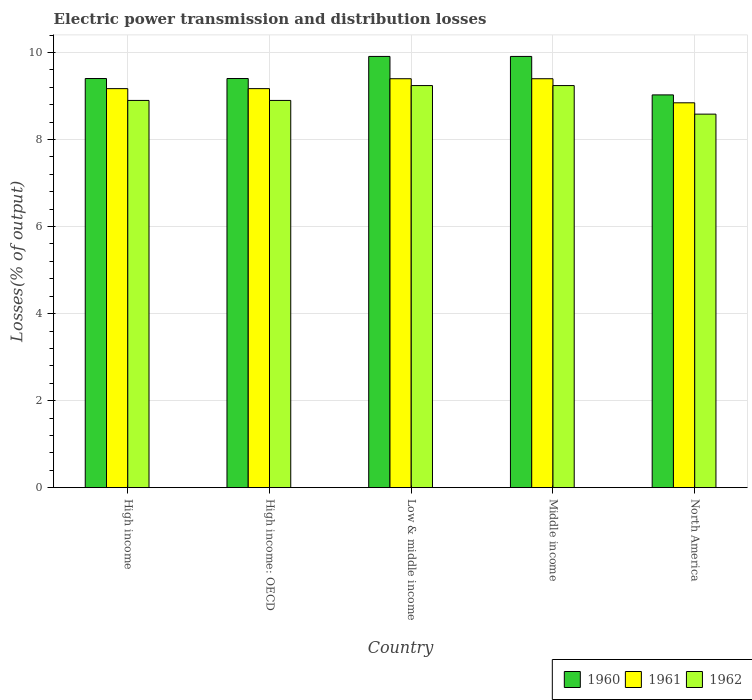How many groups of bars are there?
Your response must be concise. 5. Are the number of bars per tick equal to the number of legend labels?
Give a very brief answer. Yes. How many bars are there on the 4th tick from the left?
Your answer should be very brief. 3. What is the label of the 2nd group of bars from the left?
Keep it short and to the point. High income: OECD. What is the electric power transmission and distribution losses in 1960 in High income: OECD?
Make the answer very short. 9.4. Across all countries, what is the maximum electric power transmission and distribution losses in 1961?
Ensure brevity in your answer.  9.4. Across all countries, what is the minimum electric power transmission and distribution losses in 1962?
Offer a very short reply. 8.59. In which country was the electric power transmission and distribution losses in 1960 maximum?
Make the answer very short. Low & middle income. In which country was the electric power transmission and distribution losses in 1962 minimum?
Offer a terse response. North America. What is the total electric power transmission and distribution losses in 1961 in the graph?
Make the answer very short. 45.99. What is the difference between the electric power transmission and distribution losses in 1960 in High income and that in Low & middle income?
Give a very brief answer. -0.51. What is the difference between the electric power transmission and distribution losses in 1962 in High income and the electric power transmission and distribution losses in 1961 in Middle income?
Ensure brevity in your answer.  -0.5. What is the average electric power transmission and distribution losses in 1960 per country?
Keep it short and to the point. 9.53. What is the difference between the electric power transmission and distribution losses of/in 1961 and electric power transmission and distribution losses of/in 1962 in Middle income?
Keep it short and to the point. 0.16. What is the ratio of the electric power transmission and distribution losses in 1960 in Low & middle income to that in Middle income?
Make the answer very short. 1. What is the difference between the highest and the second highest electric power transmission and distribution losses in 1960?
Offer a very short reply. 0.51. What is the difference between the highest and the lowest electric power transmission and distribution losses in 1960?
Ensure brevity in your answer.  0.88. In how many countries, is the electric power transmission and distribution losses in 1962 greater than the average electric power transmission and distribution losses in 1962 taken over all countries?
Your response must be concise. 2. What does the 2nd bar from the left in Low & middle income represents?
Your response must be concise. 1961. How many bars are there?
Give a very brief answer. 15. Are all the bars in the graph horizontal?
Your response must be concise. No. How many countries are there in the graph?
Your answer should be very brief. 5. What is the difference between two consecutive major ticks on the Y-axis?
Give a very brief answer. 2. How many legend labels are there?
Offer a very short reply. 3. What is the title of the graph?
Give a very brief answer. Electric power transmission and distribution losses. Does "1989" appear as one of the legend labels in the graph?
Provide a succinct answer. No. What is the label or title of the X-axis?
Your answer should be very brief. Country. What is the label or title of the Y-axis?
Keep it short and to the point. Losses(% of output). What is the Losses(% of output) of 1960 in High income?
Your answer should be very brief. 9.4. What is the Losses(% of output) of 1961 in High income?
Your answer should be compact. 9.17. What is the Losses(% of output) of 1962 in High income?
Ensure brevity in your answer.  8.9. What is the Losses(% of output) of 1960 in High income: OECD?
Provide a succinct answer. 9.4. What is the Losses(% of output) in 1961 in High income: OECD?
Offer a terse response. 9.17. What is the Losses(% of output) of 1962 in High income: OECD?
Provide a succinct answer. 8.9. What is the Losses(% of output) in 1960 in Low & middle income?
Your answer should be compact. 9.91. What is the Losses(% of output) of 1961 in Low & middle income?
Make the answer very short. 9.4. What is the Losses(% of output) of 1962 in Low & middle income?
Offer a very short reply. 9.24. What is the Losses(% of output) in 1960 in Middle income?
Make the answer very short. 9.91. What is the Losses(% of output) in 1961 in Middle income?
Make the answer very short. 9.4. What is the Losses(% of output) of 1962 in Middle income?
Keep it short and to the point. 9.24. What is the Losses(% of output) of 1960 in North America?
Offer a very short reply. 9.03. What is the Losses(% of output) of 1961 in North America?
Your response must be concise. 8.85. What is the Losses(% of output) of 1962 in North America?
Your answer should be very brief. 8.59. Across all countries, what is the maximum Losses(% of output) in 1960?
Make the answer very short. 9.91. Across all countries, what is the maximum Losses(% of output) of 1961?
Give a very brief answer. 9.4. Across all countries, what is the maximum Losses(% of output) in 1962?
Provide a short and direct response. 9.24. Across all countries, what is the minimum Losses(% of output) of 1960?
Ensure brevity in your answer.  9.03. Across all countries, what is the minimum Losses(% of output) in 1961?
Your answer should be compact. 8.85. Across all countries, what is the minimum Losses(% of output) in 1962?
Your response must be concise. 8.59. What is the total Losses(% of output) of 1960 in the graph?
Ensure brevity in your answer.  47.66. What is the total Losses(% of output) in 1961 in the graph?
Your response must be concise. 45.99. What is the total Losses(% of output) in 1962 in the graph?
Offer a terse response. 44.87. What is the difference between the Losses(% of output) in 1961 in High income and that in High income: OECD?
Keep it short and to the point. 0. What is the difference between the Losses(% of output) of 1962 in High income and that in High income: OECD?
Your answer should be compact. 0. What is the difference between the Losses(% of output) of 1960 in High income and that in Low & middle income?
Keep it short and to the point. -0.51. What is the difference between the Losses(% of output) in 1961 in High income and that in Low & middle income?
Offer a terse response. -0.23. What is the difference between the Losses(% of output) of 1962 in High income and that in Low & middle income?
Your answer should be compact. -0.34. What is the difference between the Losses(% of output) in 1960 in High income and that in Middle income?
Offer a very short reply. -0.51. What is the difference between the Losses(% of output) in 1961 in High income and that in Middle income?
Provide a short and direct response. -0.23. What is the difference between the Losses(% of output) of 1962 in High income and that in Middle income?
Your answer should be very brief. -0.34. What is the difference between the Losses(% of output) of 1960 in High income and that in North America?
Your answer should be very brief. 0.38. What is the difference between the Losses(% of output) of 1961 in High income and that in North America?
Make the answer very short. 0.33. What is the difference between the Losses(% of output) in 1962 in High income and that in North America?
Give a very brief answer. 0.31. What is the difference between the Losses(% of output) in 1960 in High income: OECD and that in Low & middle income?
Provide a short and direct response. -0.51. What is the difference between the Losses(% of output) in 1961 in High income: OECD and that in Low & middle income?
Offer a terse response. -0.23. What is the difference between the Losses(% of output) in 1962 in High income: OECD and that in Low & middle income?
Ensure brevity in your answer.  -0.34. What is the difference between the Losses(% of output) in 1960 in High income: OECD and that in Middle income?
Your response must be concise. -0.51. What is the difference between the Losses(% of output) in 1961 in High income: OECD and that in Middle income?
Keep it short and to the point. -0.23. What is the difference between the Losses(% of output) in 1962 in High income: OECD and that in Middle income?
Ensure brevity in your answer.  -0.34. What is the difference between the Losses(% of output) of 1960 in High income: OECD and that in North America?
Provide a succinct answer. 0.38. What is the difference between the Losses(% of output) of 1961 in High income: OECD and that in North America?
Make the answer very short. 0.33. What is the difference between the Losses(% of output) of 1962 in High income: OECD and that in North America?
Ensure brevity in your answer.  0.31. What is the difference between the Losses(% of output) in 1960 in Low & middle income and that in Middle income?
Keep it short and to the point. 0. What is the difference between the Losses(% of output) of 1961 in Low & middle income and that in Middle income?
Make the answer very short. 0. What is the difference between the Losses(% of output) of 1960 in Low & middle income and that in North America?
Provide a short and direct response. 0.88. What is the difference between the Losses(% of output) in 1961 in Low & middle income and that in North America?
Make the answer very short. 0.55. What is the difference between the Losses(% of output) of 1962 in Low & middle income and that in North America?
Your answer should be very brief. 0.66. What is the difference between the Losses(% of output) in 1960 in Middle income and that in North America?
Give a very brief answer. 0.88. What is the difference between the Losses(% of output) of 1961 in Middle income and that in North America?
Offer a very short reply. 0.55. What is the difference between the Losses(% of output) of 1962 in Middle income and that in North America?
Keep it short and to the point. 0.66. What is the difference between the Losses(% of output) in 1960 in High income and the Losses(% of output) in 1961 in High income: OECD?
Provide a succinct answer. 0.23. What is the difference between the Losses(% of output) of 1960 in High income and the Losses(% of output) of 1962 in High income: OECD?
Make the answer very short. 0.5. What is the difference between the Losses(% of output) in 1961 in High income and the Losses(% of output) in 1962 in High income: OECD?
Make the answer very short. 0.27. What is the difference between the Losses(% of output) in 1960 in High income and the Losses(% of output) in 1961 in Low & middle income?
Offer a very short reply. 0. What is the difference between the Losses(% of output) of 1960 in High income and the Losses(% of output) of 1962 in Low & middle income?
Your answer should be very brief. 0.16. What is the difference between the Losses(% of output) in 1961 in High income and the Losses(% of output) in 1962 in Low & middle income?
Your answer should be very brief. -0.07. What is the difference between the Losses(% of output) in 1960 in High income and the Losses(% of output) in 1961 in Middle income?
Make the answer very short. 0. What is the difference between the Losses(% of output) in 1960 in High income and the Losses(% of output) in 1962 in Middle income?
Your response must be concise. 0.16. What is the difference between the Losses(% of output) in 1961 in High income and the Losses(% of output) in 1962 in Middle income?
Give a very brief answer. -0.07. What is the difference between the Losses(% of output) of 1960 in High income and the Losses(% of output) of 1961 in North America?
Offer a very short reply. 0.56. What is the difference between the Losses(% of output) in 1960 in High income and the Losses(% of output) in 1962 in North America?
Your answer should be very brief. 0.82. What is the difference between the Losses(% of output) in 1961 in High income and the Losses(% of output) in 1962 in North America?
Offer a terse response. 0.59. What is the difference between the Losses(% of output) in 1960 in High income: OECD and the Losses(% of output) in 1961 in Low & middle income?
Offer a terse response. 0. What is the difference between the Losses(% of output) of 1960 in High income: OECD and the Losses(% of output) of 1962 in Low & middle income?
Offer a terse response. 0.16. What is the difference between the Losses(% of output) of 1961 in High income: OECD and the Losses(% of output) of 1962 in Low & middle income?
Your answer should be compact. -0.07. What is the difference between the Losses(% of output) of 1960 in High income: OECD and the Losses(% of output) of 1961 in Middle income?
Your answer should be very brief. 0. What is the difference between the Losses(% of output) in 1960 in High income: OECD and the Losses(% of output) in 1962 in Middle income?
Ensure brevity in your answer.  0.16. What is the difference between the Losses(% of output) of 1961 in High income: OECD and the Losses(% of output) of 1962 in Middle income?
Ensure brevity in your answer.  -0.07. What is the difference between the Losses(% of output) of 1960 in High income: OECD and the Losses(% of output) of 1961 in North America?
Your answer should be compact. 0.56. What is the difference between the Losses(% of output) of 1960 in High income: OECD and the Losses(% of output) of 1962 in North America?
Your answer should be compact. 0.82. What is the difference between the Losses(% of output) of 1961 in High income: OECD and the Losses(% of output) of 1962 in North America?
Provide a succinct answer. 0.59. What is the difference between the Losses(% of output) in 1960 in Low & middle income and the Losses(% of output) in 1961 in Middle income?
Make the answer very short. 0.51. What is the difference between the Losses(% of output) in 1960 in Low & middle income and the Losses(% of output) in 1962 in Middle income?
Offer a very short reply. 0.67. What is the difference between the Losses(% of output) in 1961 in Low & middle income and the Losses(% of output) in 1962 in Middle income?
Offer a very short reply. 0.16. What is the difference between the Losses(% of output) of 1960 in Low & middle income and the Losses(% of output) of 1961 in North America?
Offer a terse response. 1.07. What is the difference between the Losses(% of output) in 1960 in Low & middle income and the Losses(% of output) in 1962 in North America?
Offer a terse response. 1.33. What is the difference between the Losses(% of output) of 1961 in Low & middle income and the Losses(% of output) of 1962 in North America?
Your answer should be compact. 0.81. What is the difference between the Losses(% of output) of 1960 in Middle income and the Losses(% of output) of 1961 in North America?
Keep it short and to the point. 1.07. What is the difference between the Losses(% of output) in 1960 in Middle income and the Losses(% of output) in 1962 in North America?
Offer a terse response. 1.33. What is the difference between the Losses(% of output) in 1961 in Middle income and the Losses(% of output) in 1962 in North America?
Keep it short and to the point. 0.81. What is the average Losses(% of output) of 1960 per country?
Make the answer very short. 9.53. What is the average Losses(% of output) in 1961 per country?
Offer a terse response. 9.2. What is the average Losses(% of output) of 1962 per country?
Ensure brevity in your answer.  8.97. What is the difference between the Losses(% of output) of 1960 and Losses(% of output) of 1961 in High income?
Keep it short and to the point. 0.23. What is the difference between the Losses(% of output) in 1960 and Losses(% of output) in 1962 in High income?
Your response must be concise. 0.5. What is the difference between the Losses(% of output) in 1961 and Losses(% of output) in 1962 in High income?
Provide a short and direct response. 0.27. What is the difference between the Losses(% of output) of 1960 and Losses(% of output) of 1961 in High income: OECD?
Offer a terse response. 0.23. What is the difference between the Losses(% of output) in 1960 and Losses(% of output) in 1962 in High income: OECD?
Offer a terse response. 0.5. What is the difference between the Losses(% of output) of 1961 and Losses(% of output) of 1962 in High income: OECD?
Keep it short and to the point. 0.27. What is the difference between the Losses(% of output) in 1960 and Losses(% of output) in 1961 in Low & middle income?
Provide a succinct answer. 0.51. What is the difference between the Losses(% of output) in 1960 and Losses(% of output) in 1962 in Low & middle income?
Provide a short and direct response. 0.67. What is the difference between the Losses(% of output) of 1961 and Losses(% of output) of 1962 in Low & middle income?
Provide a succinct answer. 0.16. What is the difference between the Losses(% of output) in 1960 and Losses(% of output) in 1961 in Middle income?
Keep it short and to the point. 0.51. What is the difference between the Losses(% of output) in 1960 and Losses(% of output) in 1962 in Middle income?
Your response must be concise. 0.67. What is the difference between the Losses(% of output) of 1961 and Losses(% of output) of 1962 in Middle income?
Ensure brevity in your answer.  0.16. What is the difference between the Losses(% of output) in 1960 and Losses(% of output) in 1961 in North America?
Offer a terse response. 0.18. What is the difference between the Losses(% of output) in 1960 and Losses(% of output) in 1962 in North America?
Make the answer very short. 0.44. What is the difference between the Losses(% of output) in 1961 and Losses(% of output) in 1962 in North America?
Provide a succinct answer. 0.26. What is the ratio of the Losses(% of output) of 1960 in High income to that in Low & middle income?
Offer a very short reply. 0.95. What is the ratio of the Losses(% of output) of 1961 in High income to that in Low & middle income?
Your answer should be compact. 0.98. What is the ratio of the Losses(% of output) of 1962 in High income to that in Low & middle income?
Make the answer very short. 0.96. What is the ratio of the Losses(% of output) in 1960 in High income to that in Middle income?
Your answer should be very brief. 0.95. What is the ratio of the Losses(% of output) of 1961 in High income to that in Middle income?
Offer a very short reply. 0.98. What is the ratio of the Losses(% of output) of 1962 in High income to that in Middle income?
Give a very brief answer. 0.96. What is the ratio of the Losses(% of output) in 1960 in High income to that in North America?
Provide a succinct answer. 1.04. What is the ratio of the Losses(% of output) of 1961 in High income to that in North America?
Your answer should be compact. 1.04. What is the ratio of the Losses(% of output) in 1962 in High income to that in North America?
Offer a terse response. 1.04. What is the ratio of the Losses(% of output) in 1960 in High income: OECD to that in Low & middle income?
Your answer should be compact. 0.95. What is the ratio of the Losses(% of output) of 1961 in High income: OECD to that in Low & middle income?
Your answer should be very brief. 0.98. What is the ratio of the Losses(% of output) in 1962 in High income: OECD to that in Low & middle income?
Give a very brief answer. 0.96. What is the ratio of the Losses(% of output) of 1960 in High income: OECD to that in Middle income?
Offer a very short reply. 0.95. What is the ratio of the Losses(% of output) of 1961 in High income: OECD to that in Middle income?
Keep it short and to the point. 0.98. What is the ratio of the Losses(% of output) in 1960 in High income: OECD to that in North America?
Offer a very short reply. 1.04. What is the ratio of the Losses(% of output) in 1961 in High income: OECD to that in North America?
Offer a very short reply. 1.04. What is the ratio of the Losses(% of output) in 1962 in High income: OECD to that in North America?
Keep it short and to the point. 1.04. What is the ratio of the Losses(% of output) of 1960 in Low & middle income to that in Middle income?
Make the answer very short. 1. What is the ratio of the Losses(% of output) in 1961 in Low & middle income to that in Middle income?
Your response must be concise. 1. What is the ratio of the Losses(% of output) of 1962 in Low & middle income to that in Middle income?
Your response must be concise. 1. What is the ratio of the Losses(% of output) of 1960 in Low & middle income to that in North America?
Your answer should be compact. 1.1. What is the ratio of the Losses(% of output) of 1961 in Low & middle income to that in North America?
Your answer should be compact. 1.06. What is the ratio of the Losses(% of output) of 1962 in Low & middle income to that in North America?
Your answer should be compact. 1.08. What is the ratio of the Losses(% of output) in 1960 in Middle income to that in North America?
Your answer should be very brief. 1.1. What is the ratio of the Losses(% of output) of 1961 in Middle income to that in North America?
Ensure brevity in your answer.  1.06. What is the ratio of the Losses(% of output) in 1962 in Middle income to that in North America?
Keep it short and to the point. 1.08. What is the difference between the highest and the second highest Losses(% of output) of 1961?
Your answer should be compact. 0. What is the difference between the highest and the second highest Losses(% of output) in 1962?
Your answer should be compact. 0. What is the difference between the highest and the lowest Losses(% of output) of 1960?
Ensure brevity in your answer.  0.88. What is the difference between the highest and the lowest Losses(% of output) of 1961?
Provide a succinct answer. 0.55. What is the difference between the highest and the lowest Losses(% of output) of 1962?
Give a very brief answer. 0.66. 